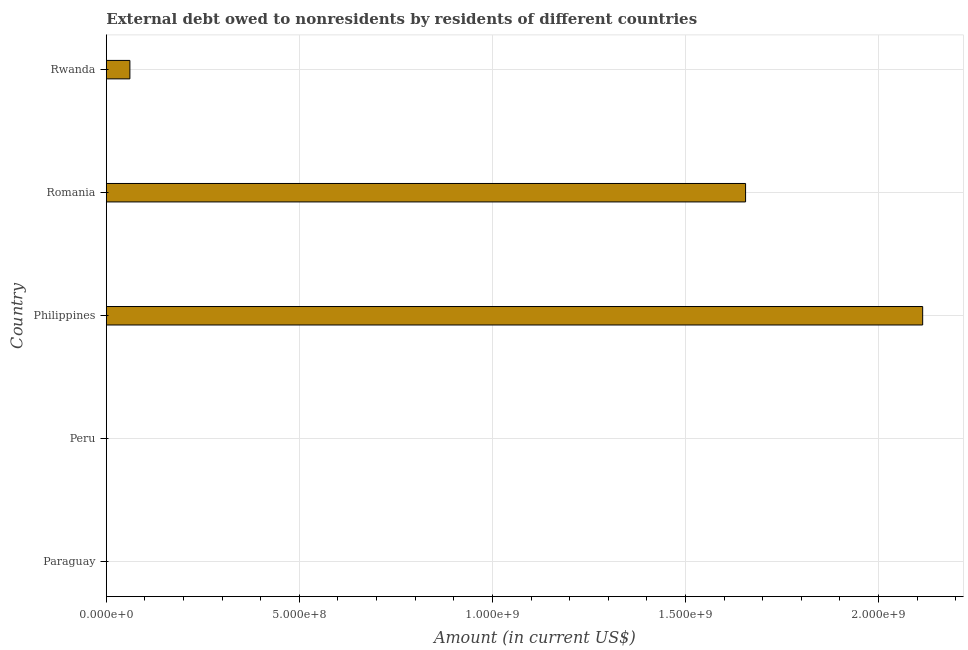Does the graph contain any zero values?
Your response must be concise. Yes. Does the graph contain grids?
Provide a short and direct response. Yes. What is the title of the graph?
Provide a succinct answer. External debt owed to nonresidents by residents of different countries. What is the label or title of the X-axis?
Provide a short and direct response. Amount (in current US$). What is the label or title of the Y-axis?
Offer a very short reply. Country. What is the debt in Philippines?
Provide a short and direct response. 2.11e+09. Across all countries, what is the maximum debt?
Provide a short and direct response. 2.11e+09. In which country was the debt maximum?
Offer a terse response. Philippines. What is the sum of the debt?
Provide a short and direct response. 3.83e+09. What is the difference between the debt in Philippines and Rwanda?
Provide a succinct answer. 2.05e+09. What is the average debt per country?
Make the answer very short. 7.66e+08. What is the median debt?
Provide a short and direct response. 6.10e+07. What is the ratio of the debt in Romania to that in Rwanda?
Ensure brevity in your answer.  27.14. Is the difference between the debt in Philippines and Rwanda greater than the difference between any two countries?
Offer a terse response. No. What is the difference between the highest and the second highest debt?
Your answer should be compact. 4.59e+08. Is the sum of the debt in Philippines and Romania greater than the maximum debt across all countries?
Ensure brevity in your answer.  Yes. What is the difference between the highest and the lowest debt?
Ensure brevity in your answer.  2.11e+09. In how many countries, is the debt greater than the average debt taken over all countries?
Provide a succinct answer. 2. How many bars are there?
Offer a terse response. 3. What is the difference between two consecutive major ticks on the X-axis?
Give a very brief answer. 5.00e+08. Are the values on the major ticks of X-axis written in scientific E-notation?
Provide a short and direct response. Yes. What is the Amount (in current US$) of Paraguay?
Make the answer very short. 0. What is the Amount (in current US$) of Philippines?
Ensure brevity in your answer.  2.11e+09. What is the Amount (in current US$) in Romania?
Keep it short and to the point. 1.66e+09. What is the Amount (in current US$) in Rwanda?
Offer a terse response. 6.10e+07. What is the difference between the Amount (in current US$) in Philippines and Romania?
Provide a succinct answer. 4.59e+08. What is the difference between the Amount (in current US$) in Philippines and Rwanda?
Offer a terse response. 2.05e+09. What is the difference between the Amount (in current US$) in Romania and Rwanda?
Give a very brief answer. 1.59e+09. What is the ratio of the Amount (in current US$) in Philippines to that in Romania?
Offer a terse response. 1.28. What is the ratio of the Amount (in current US$) in Philippines to that in Rwanda?
Keep it short and to the point. 34.66. What is the ratio of the Amount (in current US$) in Romania to that in Rwanda?
Ensure brevity in your answer.  27.14. 